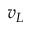Convert formula to latex. <formula><loc_0><loc_0><loc_500><loc_500>v _ { L }</formula> 